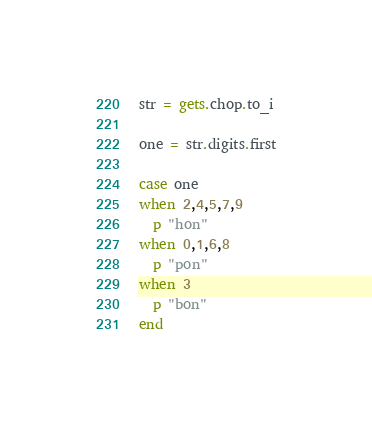<code> <loc_0><loc_0><loc_500><loc_500><_Ruby_>
str = gets.chop.to_i

one = str.digits.first

case one
when 2,4,5,7,9
  p "hon"
when 0,1,6,8
  p "pon"
when 3
  p "bon"
end</code> 